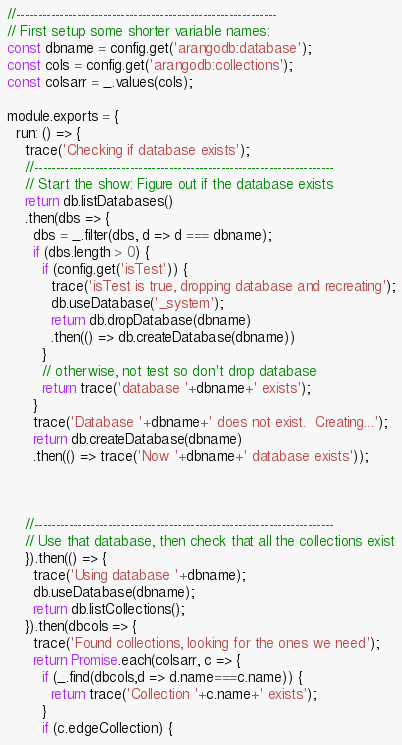Convert code to text. <code><loc_0><loc_0><loc_500><loc_500><_JavaScript_>
//------------------------------------------------------------
// First setup some shorter variable names:
const dbname = config.get('arangodb:database');
const cols = config.get('arangodb:collections');
const colsarr = _.values(cols);

module.exports = {
  run: () => {
    trace('Checking if database exists');
    //---------------------------------------------------------------------
    // Start the show: Figure out if the database exists
    return db.listDatabases()
    .then(dbs => {
      dbs = _.filter(dbs, d => d === dbname);
      if (dbs.length > 0) {
        if (config.get('isTest')) {
          trace('isTest is true, dropping database and recreating');
          db.useDatabase('_system');
          return db.dropDatabase(dbname)
          .then(() => db.createDatabase(dbname))
        }
        // otherwise, not test so don't drop database
        return trace('database '+dbname+' exists');
      }
      trace('Database '+dbname+' does not exist.  Creating...');
      return db.createDatabase(dbname)
      .then(() => trace('Now '+dbname+' database exists'));



    //---------------------------------------------------------------------
    // Use that database, then check that all the collections exist
    }).then(() => {
      trace('Using database '+dbname);
      db.useDatabase(dbname);
      return db.listCollections();
    }).then(dbcols => {
      trace('Found collections, looking for the ones we need');
      return Promise.each(colsarr, c => {
        if (_.find(dbcols,d => d.name===c.name)) {
          return trace('Collection '+c.name+' exists');
        }
        if (c.edgeCollection) {</code> 